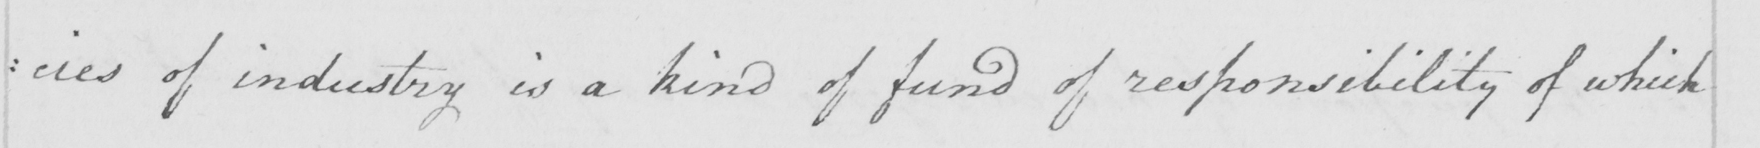Can you tell me what this handwritten text says? : cies of industry is a kind of fund of responsibility of which 